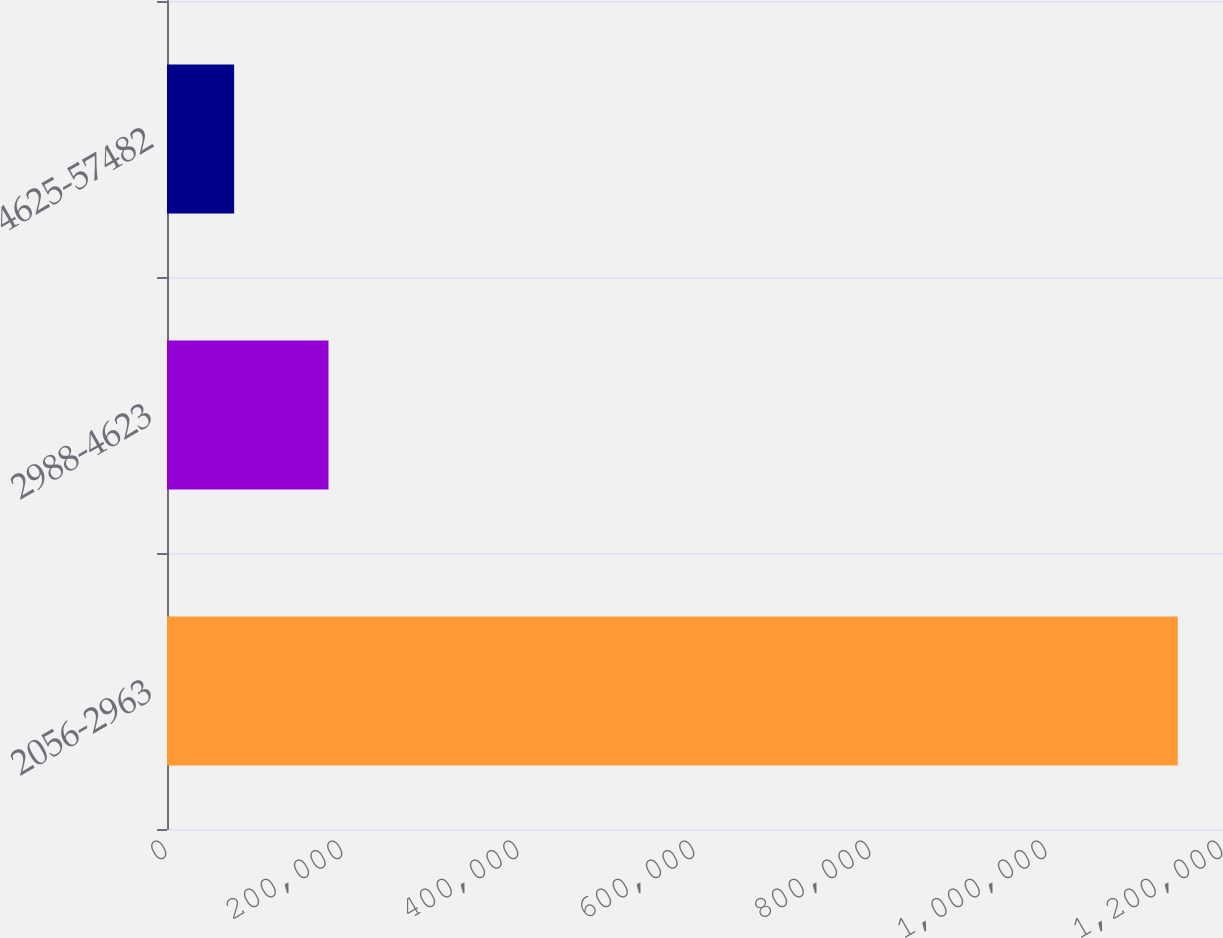Convert chart. <chart><loc_0><loc_0><loc_500><loc_500><bar_chart><fcel>2056-2963<fcel>2988-4623<fcel>4625-57482<nl><fcel>1.14861e+06<fcel>183535<fcel>76305<nl></chart> 